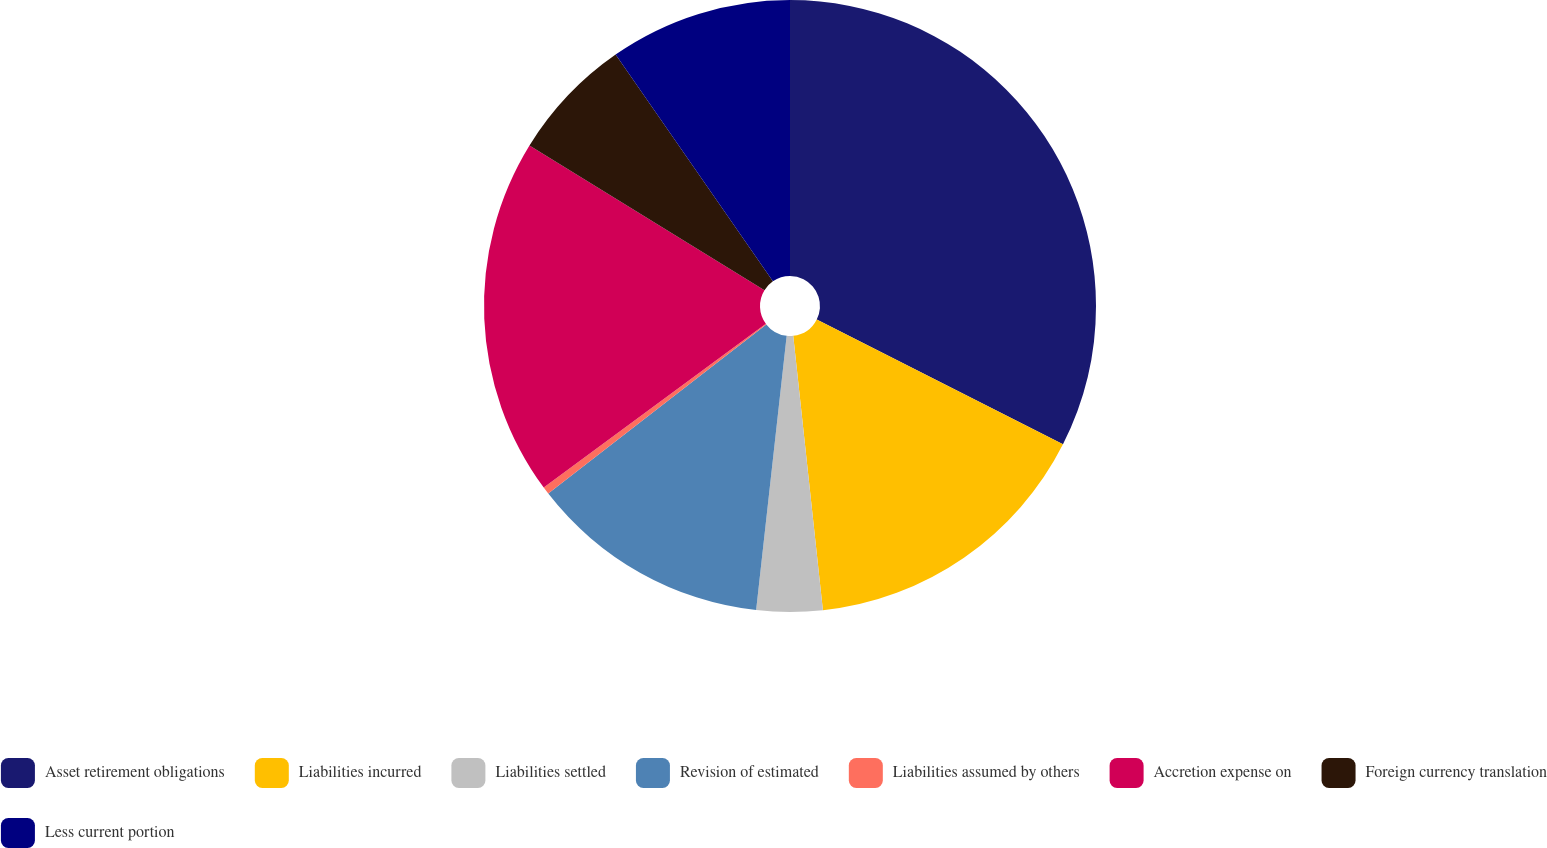Convert chart to OTSL. <chart><loc_0><loc_0><loc_500><loc_500><pie_chart><fcel>Asset retirement obligations<fcel>Liabilities incurred<fcel>Liabilities settled<fcel>Revision of estimated<fcel>Liabilities assumed by others<fcel>Accretion expense on<fcel>Foreign currency translation<fcel>Less current portion<nl><fcel>32.46%<fcel>15.82%<fcel>3.48%<fcel>12.73%<fcel>0.39%<fcel>18.9%<fcel>6.56%<fcel>9.65%<nl></chart> 